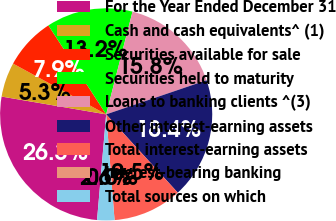Convert chart to OTSL. <chart><loc_0><loc_0><loc_500><loc_500><pie_chart><fcel>For the Year Ended December 31<fcel>Cash and cash equivalents^ (1)<fcel>Securities available for sale<fcel>Securities held to maturity<fcel>Loans to banking clients ^(3)<fcel>Other interest-earning assets<fcel>Total interest-earning assets<fcel>Interest-bearing banking<fcel>Total sources on which<nl><fcel>26.31%<fcel>5.26%<fcel>7.89%<fcel>13.16%<fcel>15.79%<fcel>18.42%<fcel>10.53%<fcel>0.0%<fcel>2.63%<nl></chart> 